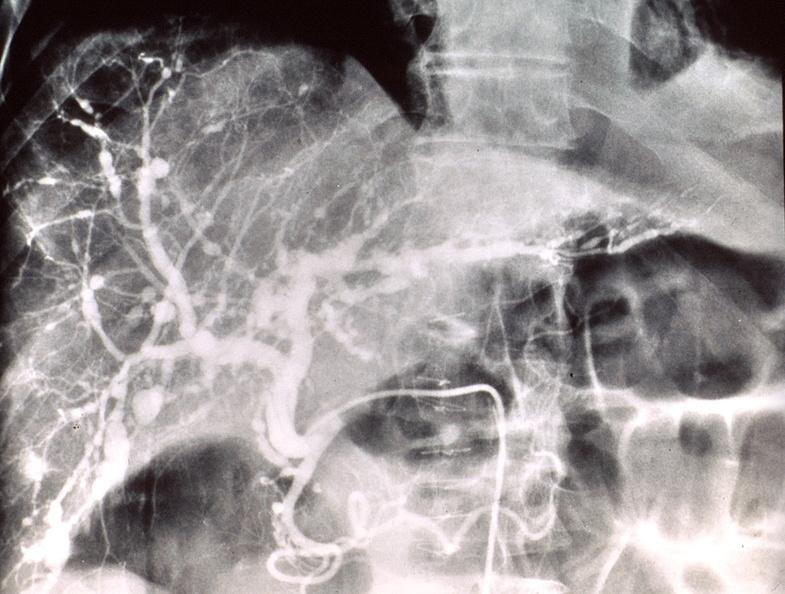s hepatobiliary present?
Answer the question using a single word or phrase. Yes 